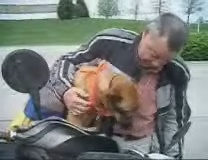Describe the objects in this image and their specific colors. I can see people in darkgray, gray, and black tones, motorcycle in darkgray, gray, black, and purple tones, and dog in darkgray, gray, tan, brown, and maroon tones in this image. 